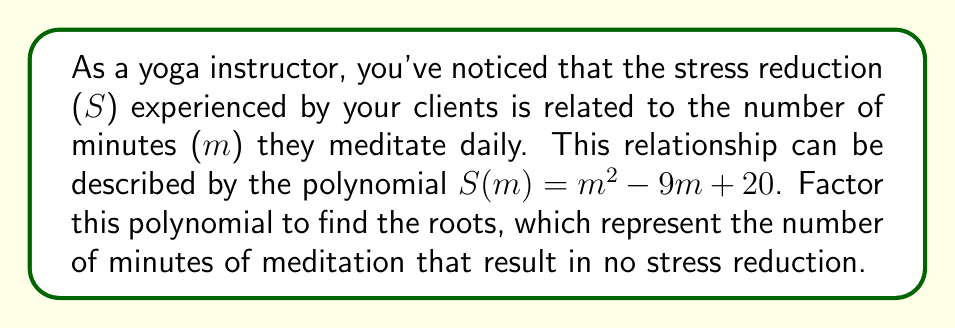Show me your answer to this math problem. To factor this polynomial, we'll use the following steps:

1) First, identify the polynomial: $S(m) = m^2 - 9m + 20$

2) This is a quadratic equation in the form $am^2 + bm + c$, where:
   $a = 1$
   $b = -9$
   $c = 20$

3) To factor, we need to find two numbers that multiply to give $ac$ (which is 20) and add up to $b$ (which is -9).

4) The factors of 20 are: 1, 2, 4, 5, 10, 20
   We need to find a pair that adds up to -9.
   We can see that -5 and -4 work: (-5)(-4) = 20 and (-5) + (-4) = -9

5) Rewrite the middle term using these numbers:
   $S(m) = m^2 - 5m - 4m + 20$

6) Factor by grouping:
   $S(m) = (m^2 - 5m) + (-4m + 20)$
   $S(m) = m(m - 5) - 4(m - 5)$
   $S(m) = (m - 5)(m - 4)$

This factored form shows that the roots of the polynomial (where $S(m) = 0$) are at $m = 5$ and $m = 4$.
Answer: $S(m) = (m - 5)(m - 4)$ 